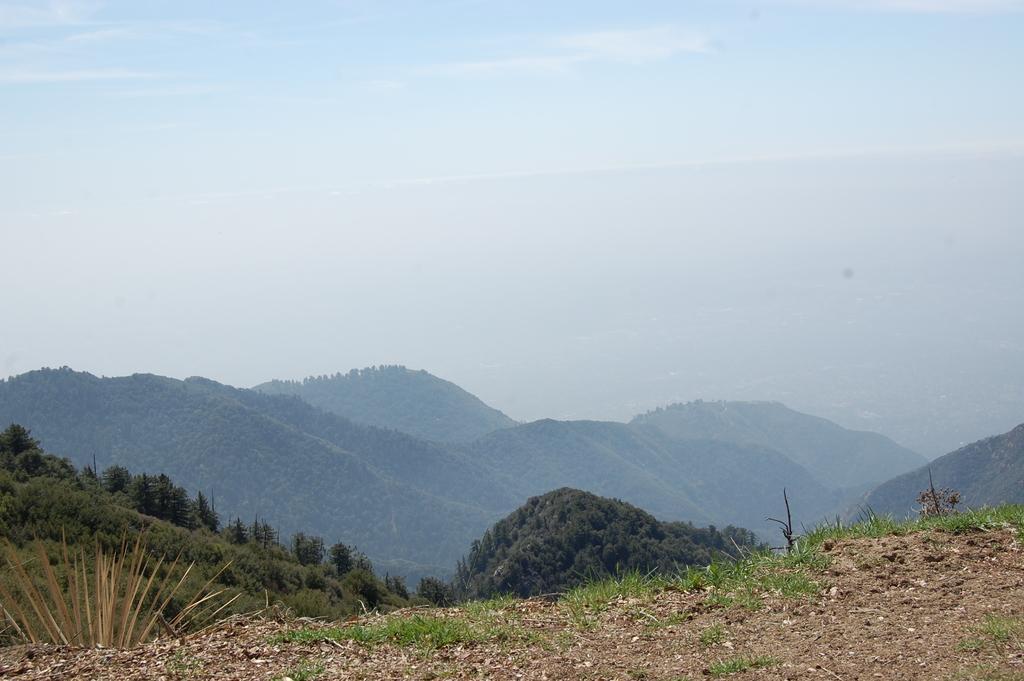In one or two sentences, can you explain what this image depicts? This picture shows trees on the hills and we see a blue cloudy sky. 